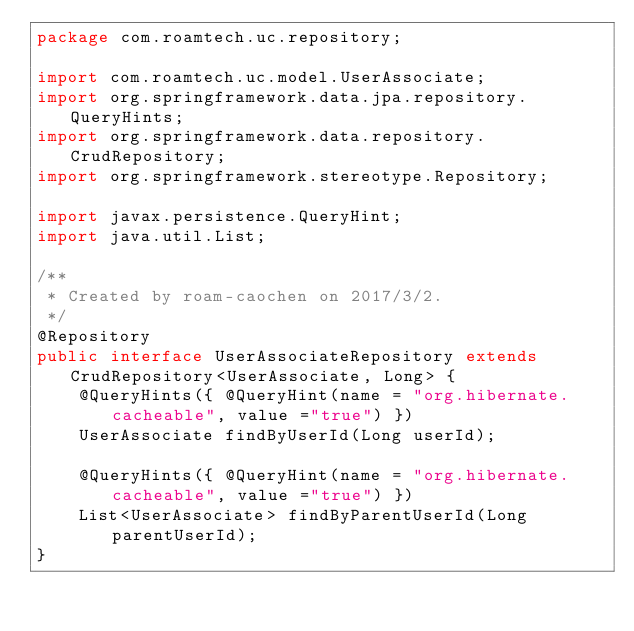<code> <loc_0><loc_0><loc_500><loc_500><_Java_>package com.roamtech.uc.repository;

import com.roamtech.uc.model.UserAssociate;
import org.springframework.data.jpa.repository.QueryHints;
import org.springframework.data.repository.CrudRepository;
import org.springframework.stereotype.Repository;

import javax.persistence.QueryHint;
import java.util.List;

/**
 * Created by roam-caochen on 2017/3/2.
 */
@Repository
public interface UserAssociateRepository extends CrudRepository<UserAssociate, Long> {
    @QueryHints({ @QueryHint(name = "org.hibernate.cacheable", value ="true") })
    UserAssociate findByUserId(Long userId);

    @QueryHints({ @QueryHint(name = "org.hibernate.cacheable", value ="true") })
    List<UserAssociate> findByParentUserId(Long parentUserId);
}
</code> 